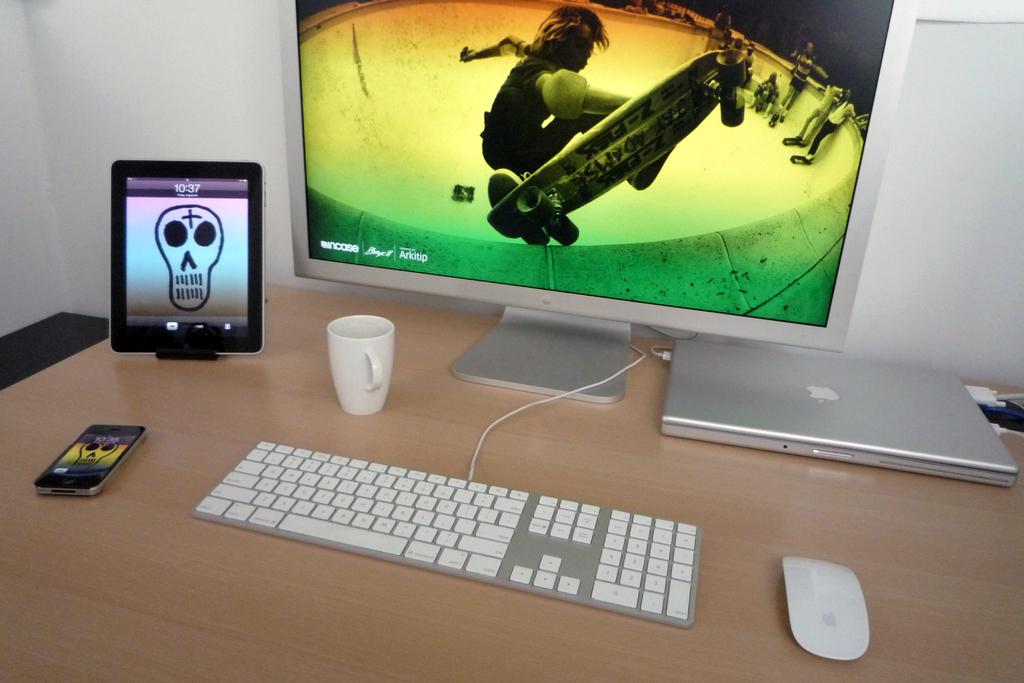What time is displayed on the tablet to the left of the monitor?
Your answer should be very brief. 10:37. What is the computer brand?
Your answer should be very brief. Apple. 